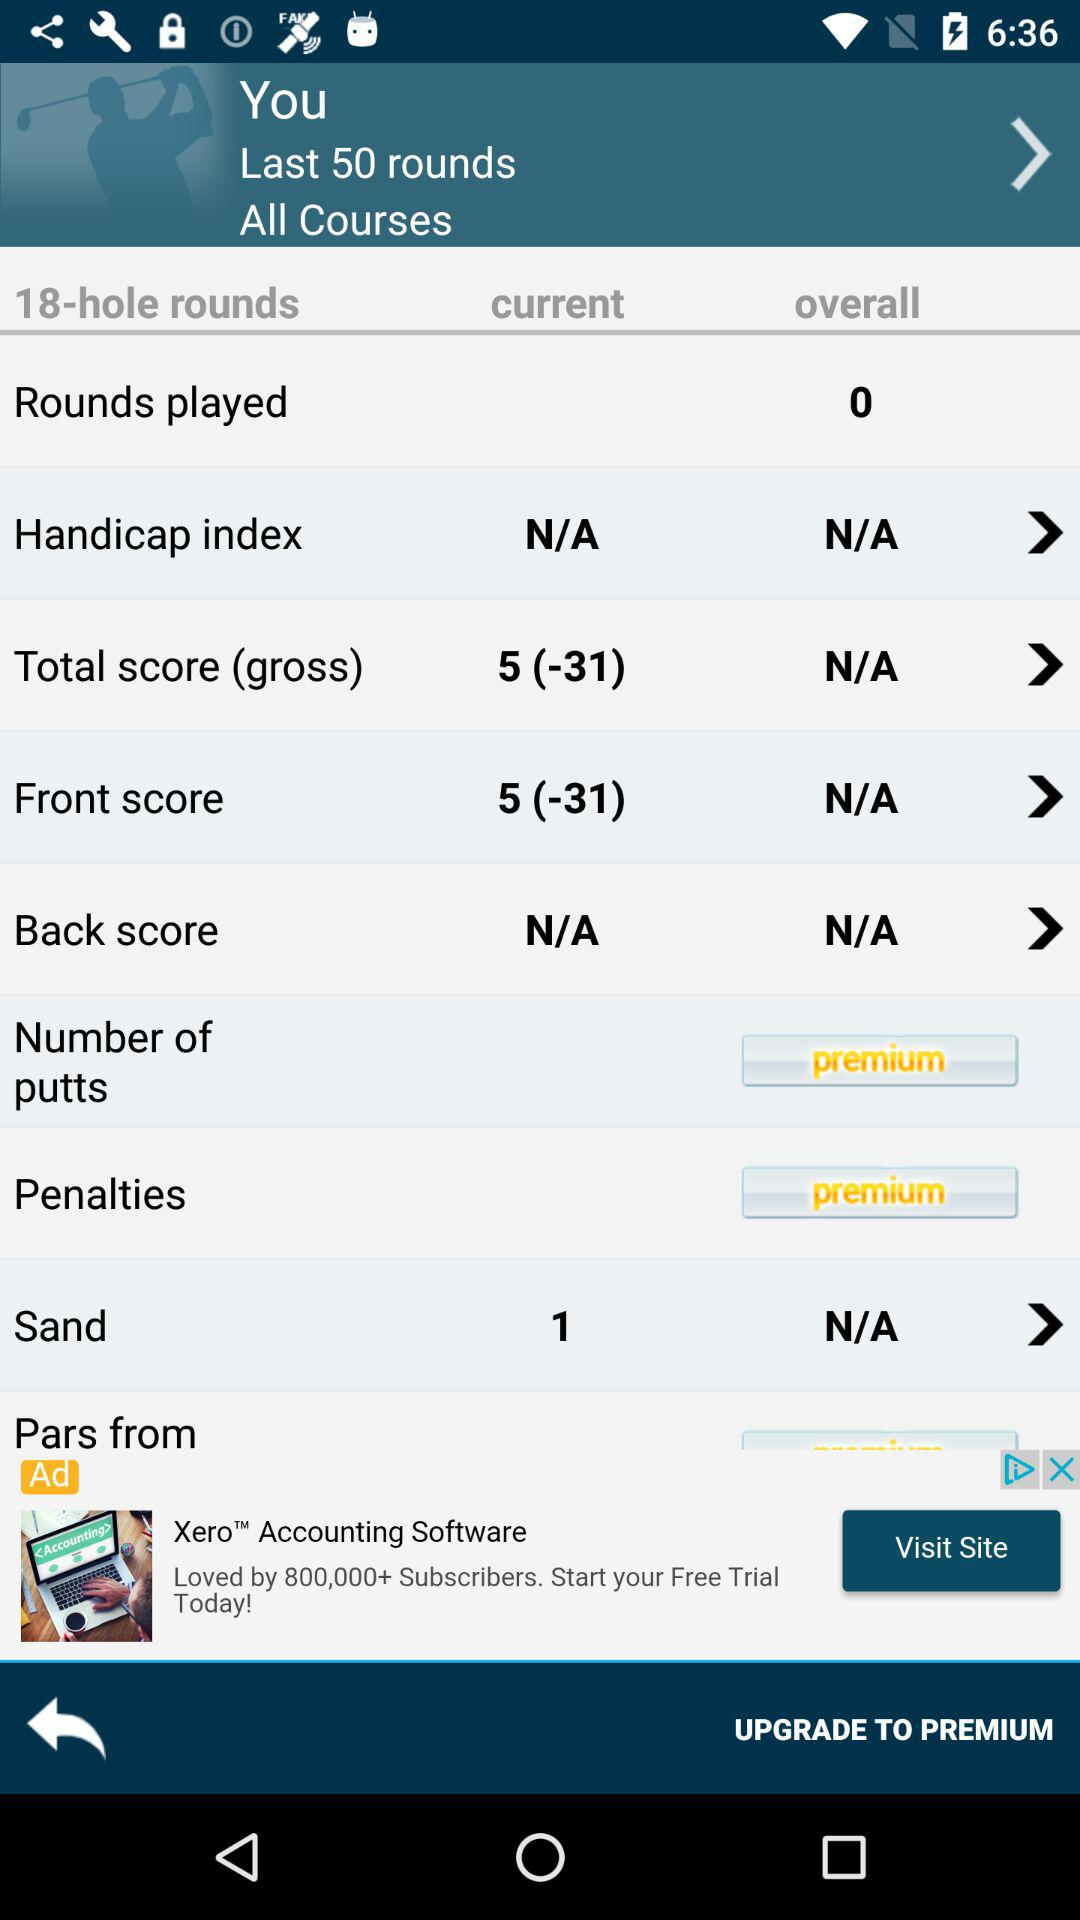How many holes are there in a round? There are 18 holes in a round. 